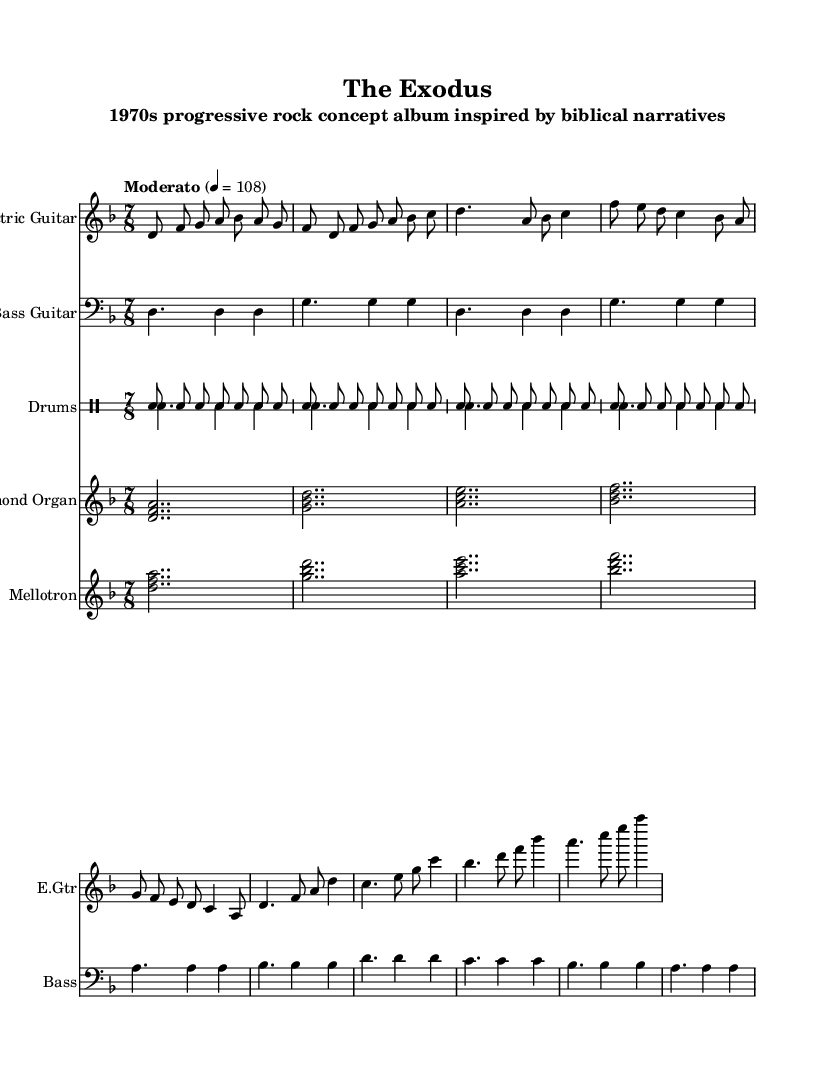What is the key signature of this music? The key signature is D minor, which is indicated by one flat (B♭) in the key signature section at the beginning of the score.
Answer: D minor What is the time signature of this music? The time signature is 7/8, as shown at the beginning of the score where the time signature is written clearly.
Answer: 7/8 What is the tempo marking for this piece? The tempo marking indicates "Moderato," with a metronome marking of quarter note equals 108, which sets a moderate speed for the performance.
Answer: Moderato 4 = 108 How many measures are marked in the electric guitar part? By counting the number of groups of notes and rests, there are a total of 8 measures in the electric guitar part.
Answer: 8 Which instruments are featured in this score? The score features Electric Guitar, Bass Guitar, Drums, Hammond Organ, and Mellotron, all listed in their respective staff headers.
Answer: Electric Guitar, Bass Guitar, Drums, Hammond Organ, Mellotron In which section does the chorus begin in the electric guitar part? The chorus begins after the verse section, identified by the presence of a new melody and chord structure emphasizing the main theme, transitioning from the verse.
Answer: After the verse What is the rhythmic pattern of the drums in the first section? The Drums section has a consistent hi-hat pattern throughout, indicated by repeated "hh," functioning as a steady pulse and creating a driving rhythm beneath the music.
Answer: Steady hi-hat pattern 